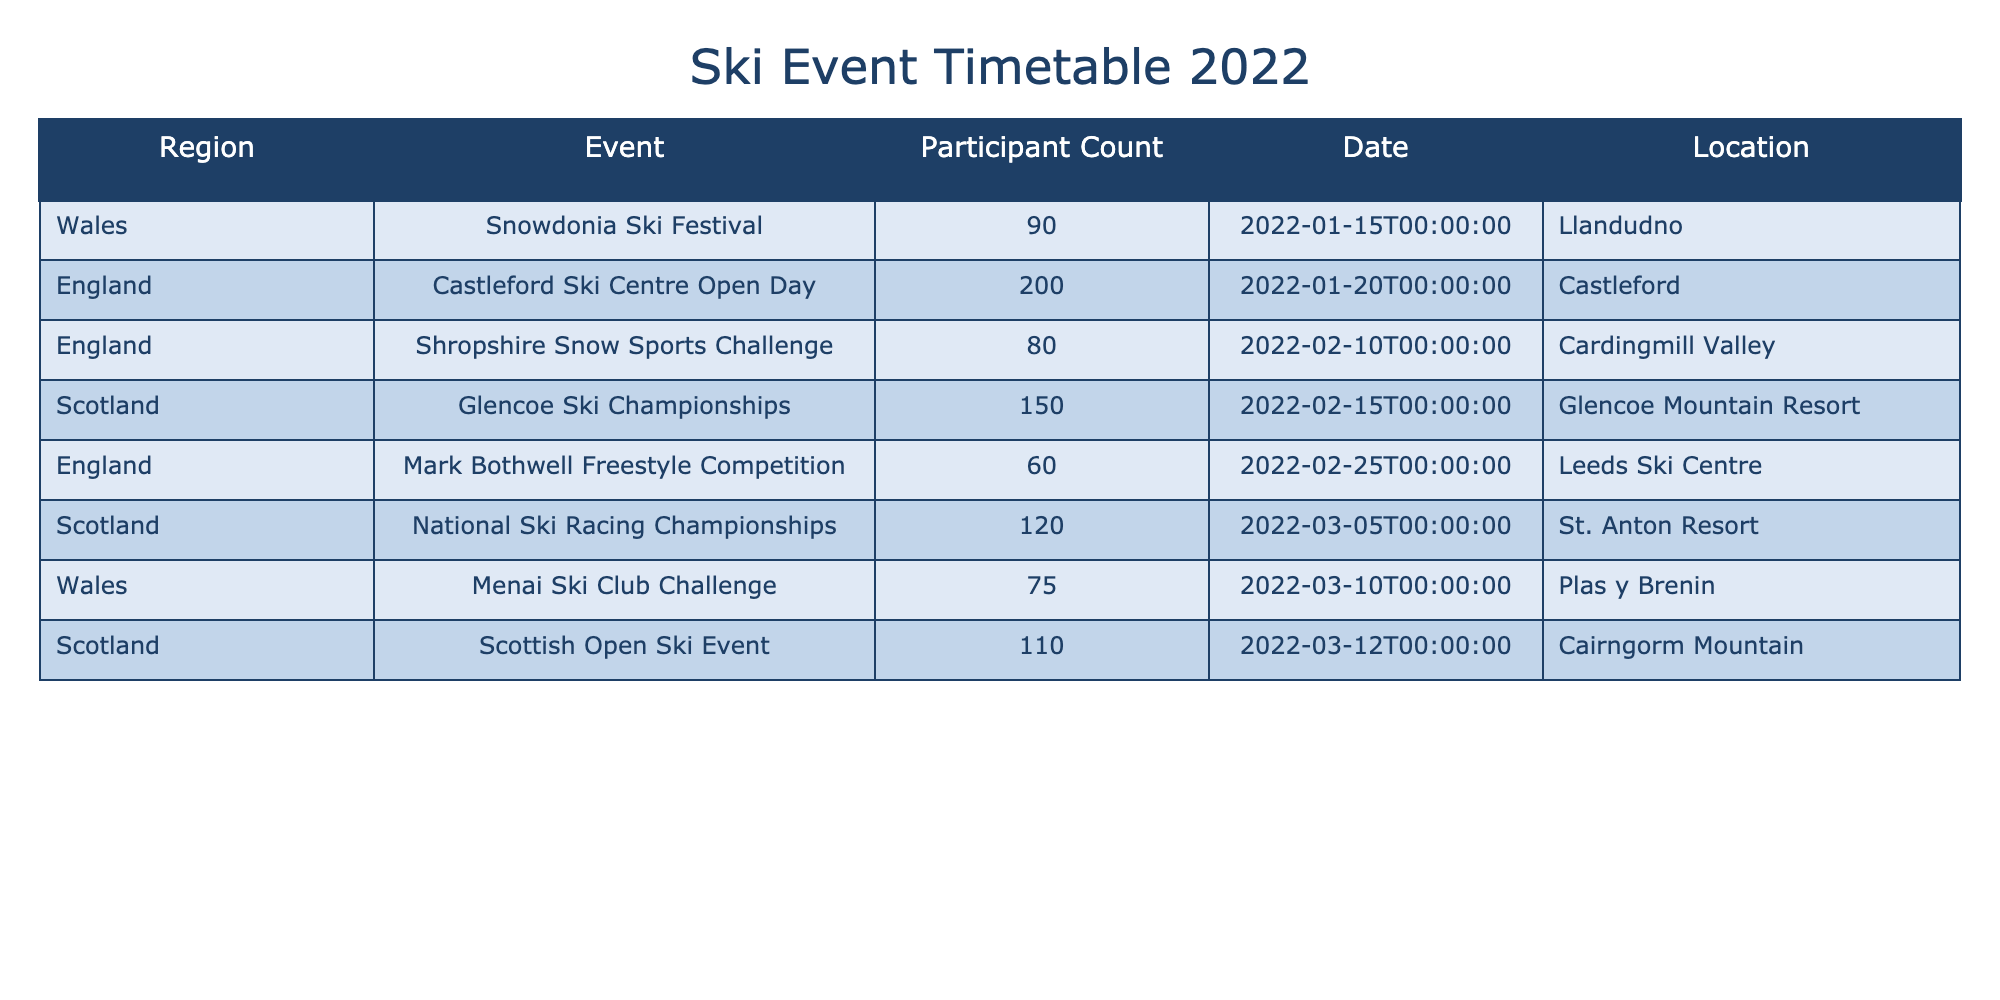What region had the highest participant count in 2022? By examining the "Participant Count" column, we find that the highest number is 200, which is listed under the "Event" for "Castleford Ski Centre Open Day" in the "Region" of England.
Answer: England Which event had the least number of participants? Looking through the "Participant Count" column, the lowest number is 60, seen under the "Mark Bothwell Freestyle Competition" in the "Region" of England.
Answer: Mark Bothwell Freestyle Competition How many total participants were there in all events across Scotland? We need to sum the participant counts for the events in Scotland. The relevant counts are 150 (Glencoe Ski Championships), 120 (National Ski Racing Championships), and 110 (Scottish Open Ski Event). Summing these gives 150 + 120 + 110 = 380.
Answer: 380 Were there more participants in events held in England than in Wales? From the table, we see England has a total of 200 (Castleford Ski Centre Open Day) + 60 (Mark Bothwell Freestyle Competition) + 80 (Shropshire Snow Sports Challenge) = 340 participants. Wales has 75 (Menai Ski Club Challenge) + 90 (Snowdonia Ski Festival) = 165 participants. Since 340 > 165, the answer is yes.
Answer: Yes What is the average number of participants per event in Scotland? The total participant counts for Scotland are 150, 120, and 110, which sum up to 380 participants across 3 events. To calculate the average, we divide the total by the number of events: 380 / 3 = approximately 126.67.
Answer: 126.67 How many events took place in Wales, and what was the total participant count for those events? There are 2 events in Wales: "Menai Ski Club Challenge" with 75 participants and "Snowdonia Ski Festival" with 90 participants. Adding these gives us 75 + 90 = 165 participants across 2 events.
Answer: 2 events, 165 participants Did any event in Wales have more than 80 participants? The events in Wales had participant counts of 75 and 90. Since 90 > 80, there was at least one event (Snowdonia Ski Festival) that meets this criterion.
Answer: Yes Which region had the fewest total participants in its events? To find this, we need the total participant counts for each region: Scotland has 380, Wales has 165, and England has 340. The lowest total is thus 165 from Wales.
Answer: Wales 